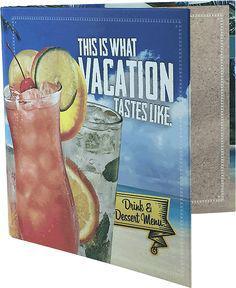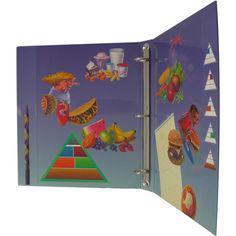The first image is the image on the left, the second image is the image on the right. For the images displayed, is the sentence "Right image shows multiple different solid colored binders of the same size." factually correct? Answer yes or no. No. The first image is the image on the left, the second image is the image on the right. For the images displayed, is the sentence "In one image, bright colored binders have large white labels on the narrow closed end." factually correct? Answer yes or no. No. 